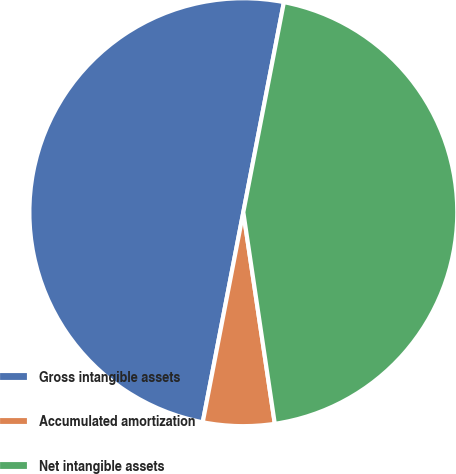Convert chart to OTSL. <chart><loc_0><loc_0><loc_500><loc_500><pie_chart><fcel>Gross intangible assets<fcel>Accumulated amortization<fcel>Net intangible assets<nl><fcel>50.0%<fcel>5.39%<fcel>44.61%<nl></chart> 